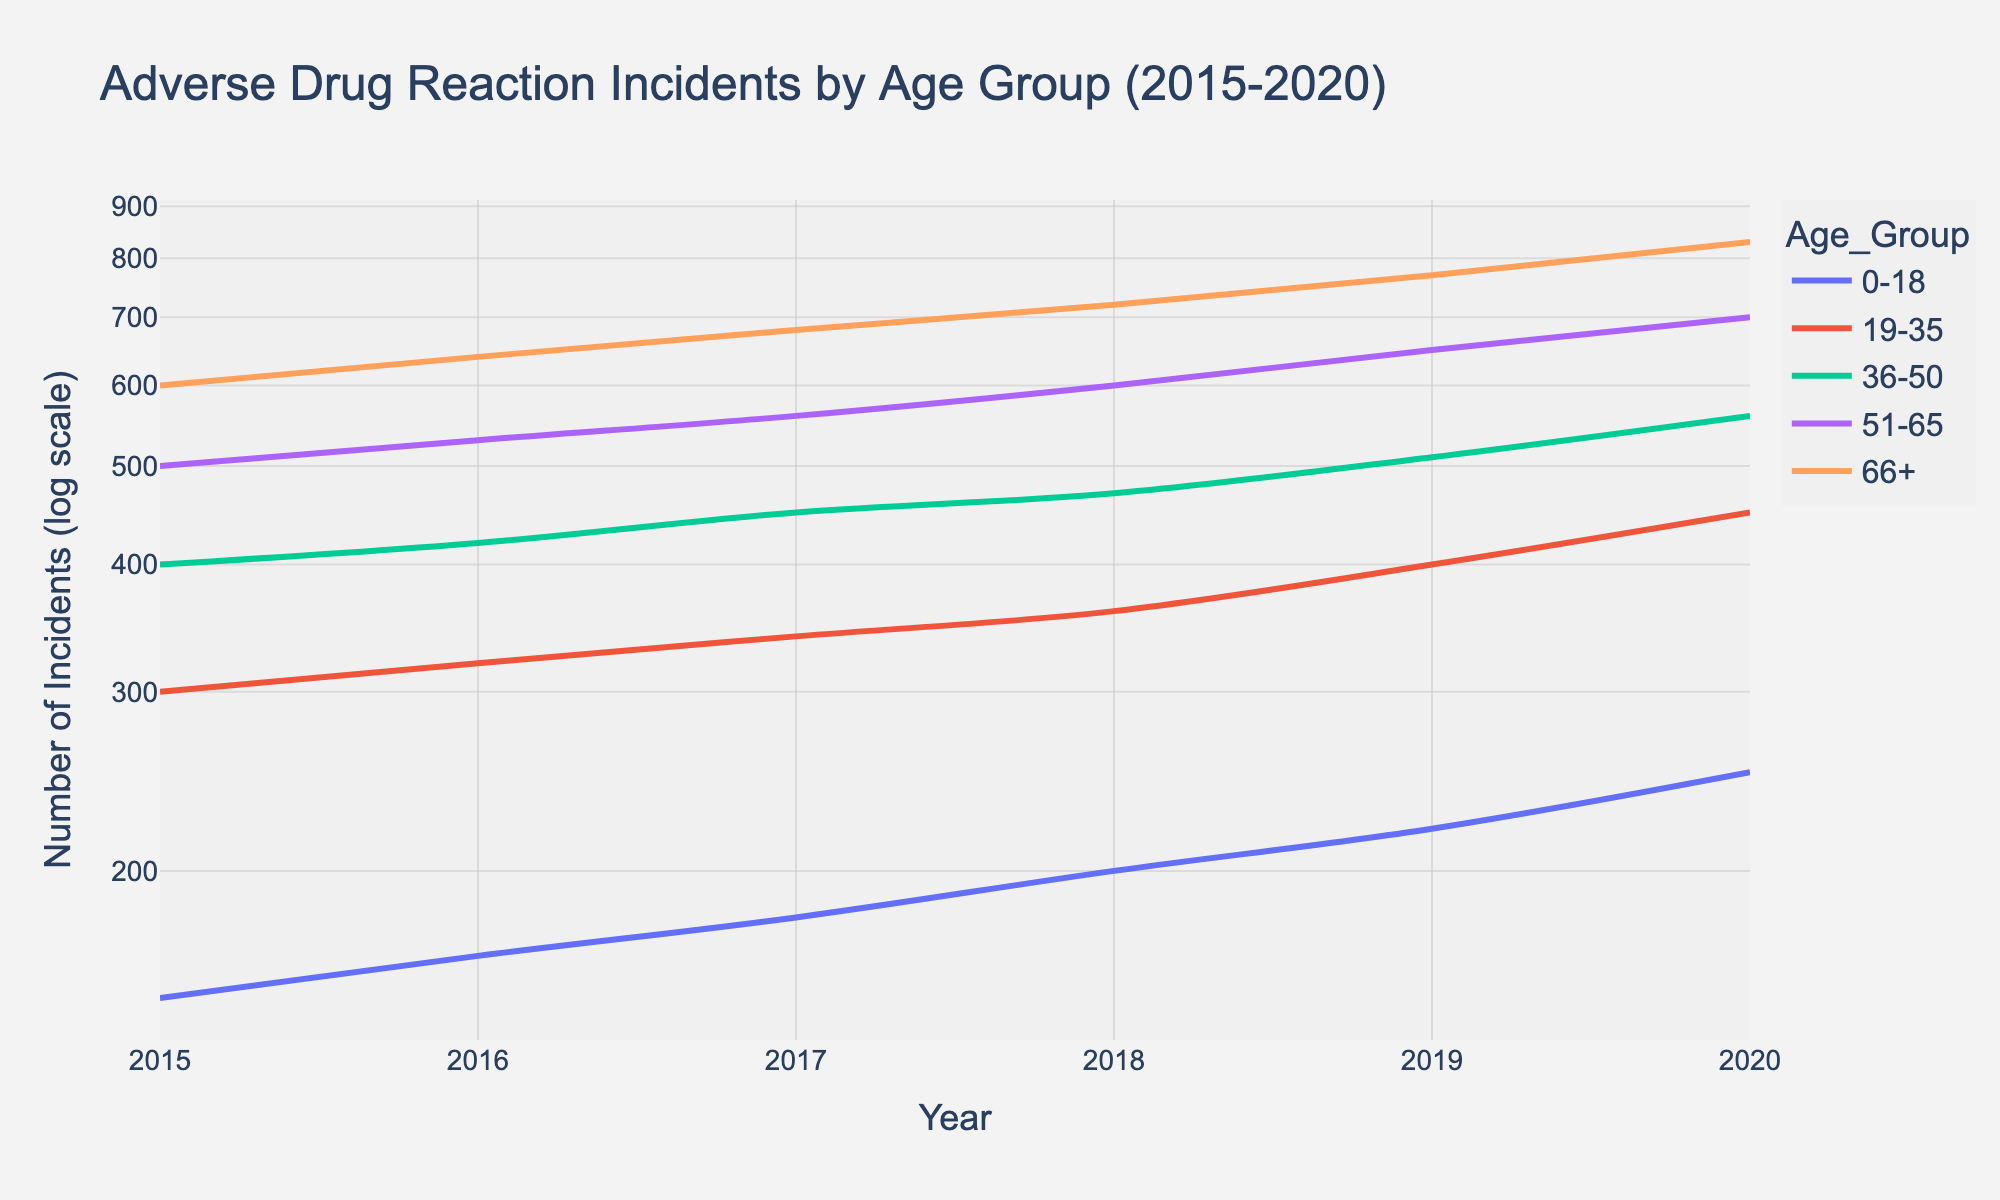What is the title of the plot? The title of the plot is usually found at the top and provides a summary of what the plot is about. In this case, it should be clear and descriptive.
Answer: Adverse Drug Reaction Incidents by Age Group (2015-2020) How many age groups are represented in the plot? To determine the number of age groups, look at the legend or the different colored lines in the plot. Each color represents a different age group.
Answer: 5 What is the general trend of adverse drug reactions over time for the age group 0-18? Examine the plot line for the 0-18 age group to identify whether it is increasing, decreasing, or remaining constant over time. Follow the slope of this line from 2015 to 2020.
Answer: Increasing Which age group has the highest number of adverse drug reactions in 2020? Observe the 2020 values on the y-axis for each age group's plot line. The group with the highest y-value in 2020 has the highest number of adverse drug reactions.
Answer: 66+ Between which two successive years did the age group 51-65 experience the highest increase in adverse drug reactions? Look at the plot line for the 51-65 age group and identify the two successive years where the change (slope) is the steepest. Calculate the difference in adverse drug reaction counts between those years.
Answer: 2017-2018 By how much did the number of adverse drug reactions increase for the age group 19-35 from 2015 to 2020? Subtract the number of adverse drug reactions in 2015 from the number in 2020 for the 19-35 age group.
Answer: 150 Which age group shows the most rapid increase in adverse drug reactions from 2015 to 2020? Compare the steepness of the lines for each age group. The steepest line indicates the most rapid increase.
Answer: 66+ How does the number of adverse drug reactions in 2019 compare between the 36-50 and the 51-65 age groups? Look at the y-values for the 36-50 and 51-65 age groups in 2019 and compare them to see which is higher or if they are equal.
Answer: 51-65 > 36-50 What is the range of adverse drug reactions in 2020 for all age groups? Identify the lowest and highest values of adverse drug reactions in 2020 for all age groups and subtract the smallest value from the largest to find the range.
Answer: 830 - 250 = 580 